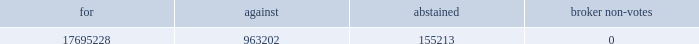Leased real property in september 2002 , we completed a sale/leaseback transaction for our 200000 square foot headquarters and manufacturing facility located in bedford , massachusetts and our 62500 square foot lorad manufacturing facility in danbury , connecticut .
The lease for these facilities , including the associated land , has a term of 20 years , with four-five year renewal options .
We sublease approximately 10000 square feet of the bedford facility to a subtenant , cmp media , under a lease which expires in may 2006 .
We also sublease approximately 11000 square feet of the bedford facility to a subtenant , genesys conferencing , under a lease which expires in february we lease a 60000 square feet of office and manufacturing space in danbury , connecticut near our lorad manufacturing facility .
This lease expires in december 2012 .
We also lease a sales and service office in belgium .
Item 3 .
Legal proceedings .
In march 2005 , we were served with a complaint filed on november 12 , 2004 by oleg sokolov with the united states district court for the district of connecticut alleging that our htc 2122 grid infringes u.s .
Patent number 5970118 .
The plaintiff is seeking to preliminarily and permanently enjoin us from infringing the patent , as well as damages resulting from the alleged infringement , treble damages and reasonable attorney fees , and such other and further relief as may be available .
On april 25 , 2005 , we filed an answer and counterclaims in response to the complaint in which we denied the plaintiff 2019s allegations and , among other things , sought declaratory relief with respect to the patent claims and damages , as well as other relief .
On october 28 , 1998 , the plaintiff had previously sued lorad , asserting , among other things , that lorad had misappropriated the plaintiff 2019s trade secrets relating to the htc grid .
This previous case was dismissed on august 28 , 2000 .
The dismissal was affirmed by the appellate court of the state of connecticut , and the united states supreme court refused to grant certiorari .
We do not believe that we infringe any valid or enforceable patents of the plaintiff .
However , while we intend to vigorously defend our interests , ongoing litigation can be costly and time consuming , and we cannot guarantee that we will prevail .
Item 4 .
Submission of matters to a vote of security holders .
At a special meeting of stockholders held november 15 , 2005 , our stockholders approved a proposal to amend our certificate of incorporation to increase the number of shares of common stock the company has authority to issue from 30 million to 90 million .
The voting results for the proposal , not adjusted for the effect of the stock split , were as follows: .
As a result of the amendment , the previously announced two-for-one stock split to be effected as a stock dividend , was paid on november 30 , 2005 to stockholders of record on november 16 , 2005. .
What is the total number of votes that participated in this proposal? 
Computations: add(table_sum(17695228, 963202), 155213)
Answer: 1273628.0. 